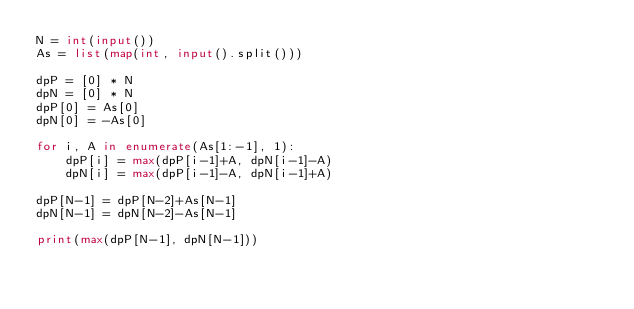Convert code to text. <code><loc_0><loc_0><loc_500><loc_500><_Python_>N = int(input())
As = list(map(int, input().split()))

dpP = [0] * N
dpN = [0] * N
dpP[0] = As[0]
dpN[0] = -As[0]

for i, A in enumerate(As[1:-1], 1):
    dpP[i] = max(dpP[i-1]+A, dpN[i-1]-A)
    dpN[i] = max(dpP[i-1]-A, dpN[i-1]+A)

dpP[N-1] = dpP[N-2]+As[N-1]
dpN[N-1] = dpN[N-2]-As[N-1]

print(max(dpP[N-1], dpN[N-1]))
</code> 